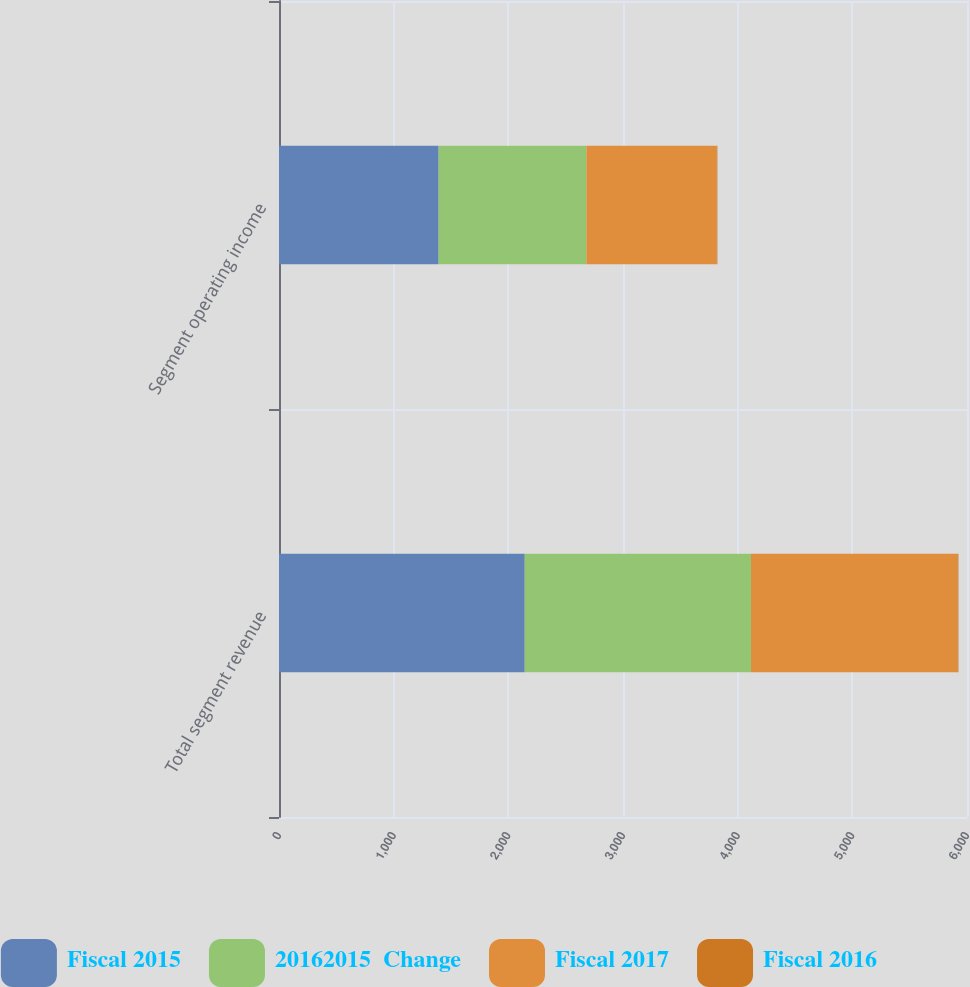Convert chart to OTSL. <chart><loc_0><loc_0><loc_500><loc_500><stacked_bar_chart><ecel><fcel>Total segment revenue<fcel>Segment operating income<nl><fcel>Fiscal 2015<fcel>2143<fcel>1392<nl><fcel>20162015  Change<fcel>1973<fcel>1289<nl><fcel>Fiscal 2017<fcel>1800<fcel>1134<nl><fcel>Fiscal 2016<fcel>9<fcel>8<nl></chart> 